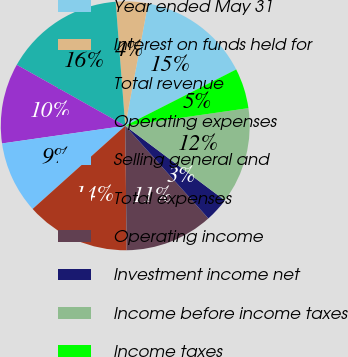Convert chart to OTSL. <chart><loc_0><loc_0><loc_500><loc_500><pie_chart><fcel>Year ended May 31<fcel>Interest on funds held for<fcel>Total revenue<fcel>Operating expenses<fcel>Selling general and<fcel>Total expenses<fcel>Operating income<fcel>Investment income net<fcel>Income before income taxes<fcel>Income taxes<nl><fcel>14.58%<fcel>4.17%<fcel>15.62%<fcel>10.42%<fcel>9.38%<fcel>13.54%<fcel>11.46%<fcel>3.13%<fcel>12.5%<fcel>5.21%<nl></chart> 